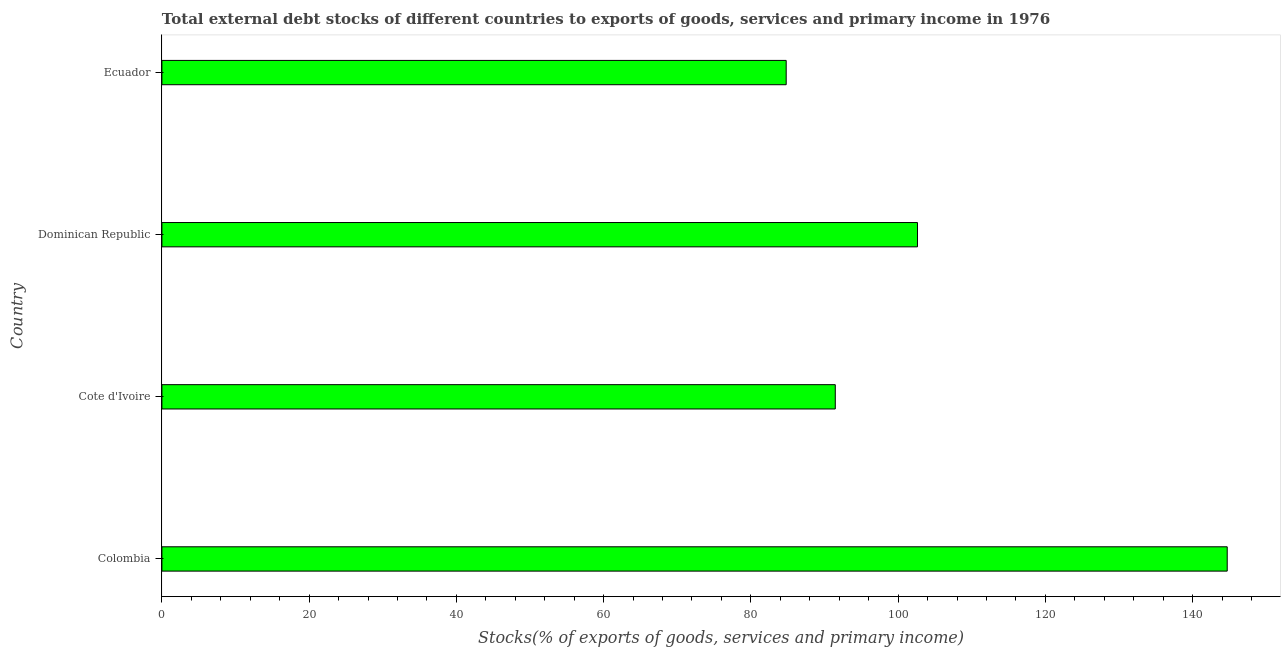Does the graph contain any zero values?
Ensure brevity in your answer.  No. What is the title of the graph?
Ensure brevity in your answer.  Total external debt stocks of different countries to exports of goods, services and primary income in 1976. What is the label or title of the X-axis?
Offer a very short reply. Stocks(% of exports of goods, services and primary income). What is the label or title of the Y-axis?
Offer a very short reply. Country. What is the external debt stocks in Dominican Republic?
Your response must be concise. 102.63. Across all countries, what is the maximum external debt stocks?
Make the answer very short. 144.7. Across all countries, what is the minimum external debt stocks?
Offer a very short reply. 84.8. In which country was the external debt stocks maximum?
Your response must be concise. Colombia. In which country was the external debt stocks minimum?
Keep it short and to the point. Ecuador. What is the sum of the external debt stocks?
Offer a very short reply. 423.59. What is the difference between the external debt stocks in Dominican Republic and Ecuador?
Ensure brevity in your answer.  17.83. What is the average external debt stocks per country?
Provide a short and direct response. 105.9. What is the median external debt stocks?
Your response must be concise. 97.05. What is the ratio of the external debt stocks in Colombia to that in Dominican Republic?
Provide a short and direct response. 1.41. Is the difference between the external debt stocks in Colombia and Cote d'Ivoire greater than the difference between any two countries?
Your answer should be compact. No. What is the difference between the highest and the second highest external debt stocks?
Make the answer very short. 42.07. What is the difference between the highest and the lowest external debt stocks?
Make the answer very short. 59.91. In how many countries, is the external debt stocks greater than the average external debt stocks taken over all countries?
Provide a succinct answer. 1. How many bars are there?
Offer a terse response. 4. What is the difference between two consecutive major ticks on the X-axis?
Your answer should be compact. 20. Are the values on the major ticks of X-axis written in scientific E-notation?
Make the answer very short. No. What is the Stocks(% of exports of goods, services and primary income) of Colombia?
Offer a very short reply. 144.7. What is the Stocks(% of exports of goods, services and primary income) in Cote d'Ivoire?
Your answer should be compact. 91.47. What is the Stocks(% of exports of goods, services and primary income) of Dominican Republic?
Offer a very short reply. 102.63. What is the Stocks(% of exports of goods, services and primary income) of Ecuador?
Provide a short and direct response. 84.8. What is the difference between the Stocks(% of exports of goods, services and primary income) in Colombia and Cote d'Ivoire?
Provide a succinct answer. 53.24. What is the difference between the Stocks(% of exports of goods, services and primary income) in Colombia and Dominican Republic?
Give a very brief answer. 42.07. What is the difference between the Stocks(% of exports of goods, services and primary income) in Colombia and Ecuador?
Give a very brief answer. 59.91. What is the difference between the Stocks(% of exports of goods, services and primary income) in Cote d'Ivoire and Dominican Republic?
Offer a very short reply. -11.16. What is the difference between the Stocks(% of exports of goods, services and primary income) in Cote d'Ivoire and Ecuador?
Offer a terse response. 6.67. What is the difference between the Stocks(% of exports of goods, services and primary income) in Dominican Republic and Ecuador?
Your response must be concise. 17.83. What is the ratio of the Stocks(% of exports of goods, services and primary income) in Colombia to that in Cote d'Ivoire?
Your response must be concise. 1.58. What is the ratio of the Stocks(% of exports of goods, services and primary income) in Colombia to that in Dominican Republic?
Your answer should be very brief. 1.41. What is the ratio of the Stocks(% of exports of goods, services and primary income) in Colombia to that in Ecuador?
Make the answer very short. 1.71. What is the ratio of the Stocks(% of exports of goods, services and primary income) in Cote d'Ivoire to that in Dominican Republic?
Your response must be concise. 0.89. What is the ratio of the Stocks(% of exports of goods, services and primary income) in Cote d'Ivoire to that in Ecuador?
Your answer should be compact. 1.08. What is the ratio of the Stocks(% of exports of goods, services and primary income) in Dominican Republic to that in Ecuador?
Your answer should be compact. 1.21. 